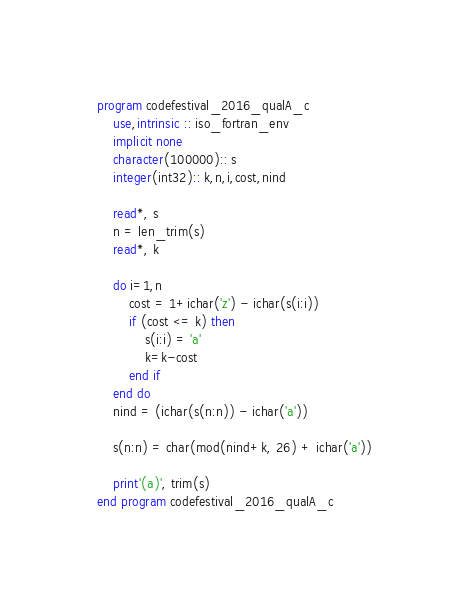Convert code to text. <code><loc_0><loc_0><loc_500><loc_500><_FORTRAN_>program codefestival_2016_qualA_c
    use,intrinsic :: iso_fortran_env
    implicit none
    character(100000):: s
    integer(int32):: k,n,i,cost,nind

    read*, s
    n = len_trim(s)
    read*, k

    do i=1,n
        cost = 1+ichar('z') - ichar(s(i:i))
        if (cost <= k) then
            s(i:i) = 'a'
            k=k-cost
        end if
    end do
    nind = (ichar(s(n:n)) - ichar('a'))
    
    s(n:n) = char(mod(nind+k, 26) + ichar('a'))

    print'(a)', trim(s)
end program codefestival_2016_qualA_c</code> 